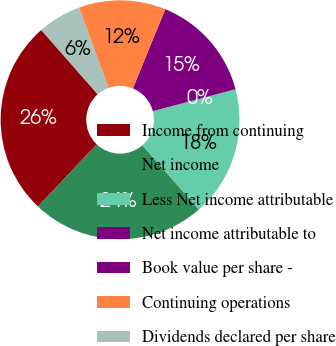<chart> <loc_0><loc_0><loc_500><loc_500><pie_chart><fcel>Income from continuing<fcel>Net income<fcel>Less Net income attributable<fcel>Net income attributable to<fcel>Book value per share -<fcel>Continuing operations<fcel>Dividends declared per share<nl><fcel>26.47%<fcel>23.53%<fcel>17.65%<fcel>0.0%<fcel>14.71%<fcel>11.76%<fcel>5.88%<nl></chart> 